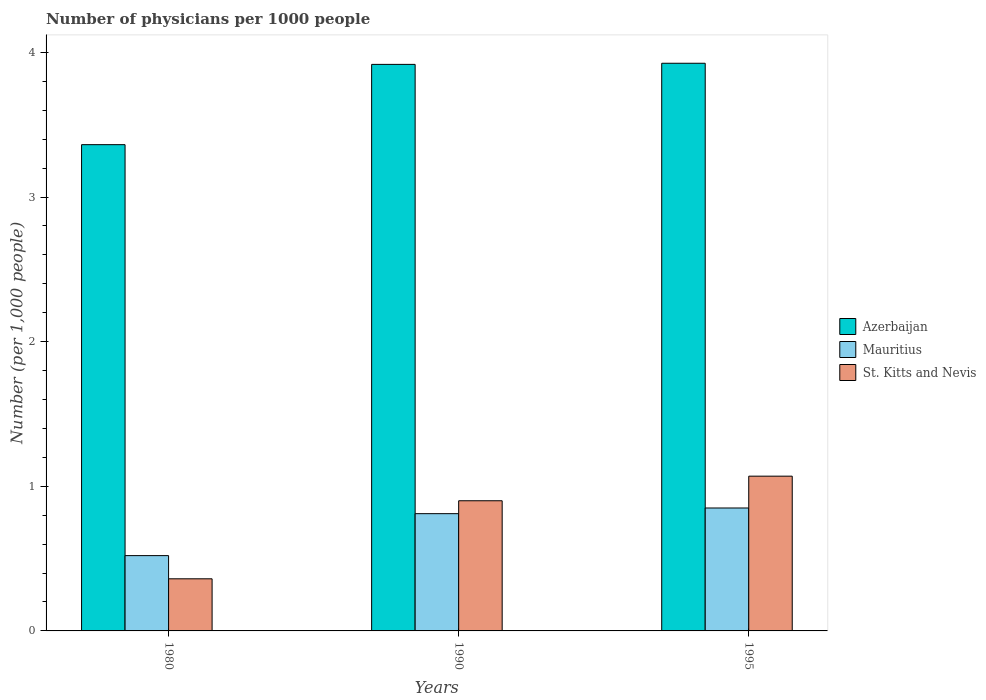How many different coloured bars are there?
Your answer should be compact. 3. Are the number of bars per tick equal to the number of legend labels?
Give a very brief answer. Yes. Are the number of bars on each tick of the X-axis equal?
Keep it short and to the point. Yes. How many bars are there on the 1st tick from the left?
Your response must be concise. 3. How many bars are there on the 1st tick from the right?
Give a very brief answer. 3. What is the number of physicians in St. Kitts and Nevis in 1990?
Ensure brevity in your answer.  0.9. Across all years, what is the maximum number of physicians in Azerbaijan?
Make the answer very short. 3.92. Across all years, what is the minimum number of physicians in Azerbaijan?
Ensure brevity in your answer.  3.36. What is the total number of physicians in Azerbaijan in the graph?
Your answer should be compact. 11.2. What is the difference between the number of physicians in Azerbaijan in 1980 and that in 1990?
Make the answer very short. -0.56. What is the difference between the number of physicians in St. Kitts and Nevis in 1995 and the number of physicians in Azerbaijan in 1990?
Offer a terse response. -2.85. What is the average number of physicians in Azerbaijan per year?
Give a very brief answer. 3.73. In the year 1990, what is the difference between the number of physicians in Azerbaijan and number of physicians in St. Kitts and Nevis?
Offer a very short reply. 3.02. In how many years, is the number of physicians in Azerbaijan greater than 2.4?
Your answer should be very brief. 3. What is the ratio of the number of physicians in St. Kitts and Nevis in 1980 to that in 1995?
Give a very brief answer. 0.34. Is the difference between the number of physicians in Azerbaijan in 1980 and 1990 greater than the difference between the number of physicians in St. Kitts and Nevis in 1980 and 1990?
Offer a terse response. No. What is the difference between the highest and the second highest number of physicians in Mauritius?
Keep it short and to the point. 0.04. What is the difference between the highest and the lowest number of physicians in Azerbaijan?
Give a very brief answer. 0.56. In how many years, is the number of physicians in St. Kitts and Nevis greater than the average number of physicians in St. Kitts and Nevis taken over all years?
Offer a very short reply. 2. Is the sum of the number of physicians in Azerbaijan in 1990 and 1995 greater than the maximum number of physicians in St. Kitts and Nevis across all years?
Offer a very short reply. Yes. What does the 1st bar from the left in 1980 represents?
Your answer should be compact. Azerbaijan. What does the 3rd bar from the right in 1990 represents?
Offer a terse response. Azerbaijan. How many years are there in the graph?
Provide a short and direct response. 3. Does the graph contain any zero values?
Your answer should be compact. No. Where does the legend appear in the graph?
Ensure brevity in your answer.  Center right. How many legend labels are there?
Your response must be concise. 3. How are the legend labels stacked?
Your response must be concise. Vertical. What is the title of the graph?
Keep it short and to the point. Number of physicians per 1000 people. Does "Aruba" appear as one of the legend labels in the graph?
Ensure brevity in your answer.  No. What is the label or title of the X-axis?
Make the answer very short. Years. What is the label or title of the Y-axis?
Keep it short and to the point. Number (per 1,0 people). What is the Number (per 1,000 people) of Azerbaijan in 1980?
Your answer should be compact. 3.36. What is the Number (per 1,000 people) of Mauritius in 1980?
Your answer should be very brief. 0.52. What is the Number (per 1,000 people) of St. Kitts and Nevis in 1980?
Your response must be concise. 0.36. What is the Number (per 1,000 people) of Azerbaijan in 1990?
Ensure brevity in your answer.  3.92. What is the Number (per 1,000 people) of Mauritius in 1990?
Provide a short and direct response. 0.81. What is the Number (per 1,000 people) in St. Kitts and Nevis in 1990?
Your response must be concise. 0.9. What is the Number (per 1,000 people) in Azerbaijan in 1995?
Your answer should be compact. 3.92. What is the Number (per 1,000 people) of Mauritius in 1995?
Provide a succinct answer. 0.85. What is the Number (per 1,000 people) in St. Kitts and Nevis in 1995?
Ensure brevity in your answer.  1.07. Across all years, what is the maximum Number (per 1,000 people) in Azerbaijan?
Ensure brevity in your answer.  3.92. Across all years, what is the maximum Number (per 1,000 people) of Mauritius?
Offer a terse response. 0.85. Across all years, what is the maximum Number (per 1,000 people) in St. Kitts and Nevis?
Keep it short and to the point. 1.07. Across all years, what is the minimum Number (per 1,000 people) in Azerbaijan?
Make the answer very short. 3.36. Across all years, what is the minimum Number (per 1,000 people) in Mauritius?
Your answer should be very brief. 0.52. Across all years, what is the minimum Number (per 1,000 people) in St. Kitts and Nevis?
Make the answer very short. 0.36. What is the total Number (per 1,000 people) in Azerbaijan in the graph?
Make the answer very short. 11.2. What is the total Number (per 1,000 people) of Mauritius in the graph?
Offer a terse response. 2.18. What is the total Number (per 1,000 people) of St. Kitts and Nevis in the graph?
Make the answer very short. 2.33. What is the difference between the Number (per 1,000 people) in Azerbaijan in 1980 and that in 1990?
Give a very brief answer. -0.56. What is the difference between the Number (per 1,000 people) in Mauritius in 1980 and that in 1990?
Offer a terse response. -0.29. What is the difference between the Number (per 1,000 people) in St. Kitts and Nevis in 1980 and that in 1990?
Your answer should be very brief. -0.54. What is the difference between the Number (per 1,000 people) of Azerbaijan in 1980 and that in 1995?
Ensure brevity in your answer.  -0.56. What is the difference between the Number (per 1,000 people) in Mauritius in 1980 and that in 1995?
Ensure brevity in your answer.  -0.33. What is the difference between the Number (per 1,000 people) of St. Kitts and Nevis in 1980 and that in 1995?
Keep it short and to the point. -0.71. What is the difference between the Number (per 1,000 people) of Azerbaijan in 1990 and that in 1995?
Provide a short and direct response. -0.01. What is the difference between the Number (per 1,000 people) in Mauritius in 1990 and that in 1995?
Offer a very short reply. -0.04. What is the difference between the Number (per 1,000 people) in St. Kitts and Nevis in 1990 and that in 1995?
Offer a very short reply. -0.17. What is the difference between the Number (per 1,000 people) of Azerbaijan in 1980 and the Number (per 1,000 people) of Mauritius in 1990?
Offer a terse response. 2.55. What is the difference between the Number (per 1,000 people) in Azerbaijan in 1980 and the Number (per 1,000 people) in St. Kitts and Nevis in 1990?
Your answer should be very brief. 2.46. What is the difference between the Number (per 1,000 people) in Mauritius in 1980 and the Number (per 1,000 people) in St. Kitts and Nevis in 1990?
Offer a very short reply. -0.38. What is the difference between the Number (per 1,000 people) in Azerbaijan in 1980 and the Number (per 1,000 people) in Mauritius in 1995?
Offer a very short reply. 2.51. What is the difference between the Number (per 1,000 people) in Azerbaijan in 1980 and the Number (per 1,000 people) in St. Kitts and Nevis in 1995?
Make the answer very short. 2.29. What is the difference between the Number (per 1,000 people) of Mauritius in 1980 and the Number (per 1,000 people) of St. Kitts and Nevis in 1995?
Give a very brief answer. -0.55. What is the difference between the Number (per 1,000 people) of Azerbaijan in 1990 and the Number (per 1,000 people) of Mauritius in 1995?
Ensure brevity in your answer.  3.07. What is the difference between the Number (per 1,000 people) of Azerbaijan in 1990 and the Number (per 1,000 people) of St. Kitts and Nevis in 1995?
Give a very brief answer. 2.85. What is the difference between the Number (per 1,000 people) in Mauritius in 1990 and the Number (per 1,000 people) in St. Kitts and Nevis in 1995?
Your response must be concise. -0.26. What is the average Number (per 1,000 people) in Azerbaijan per year?
Offer a very short reply. 3.73. What is the average Number (per 1,000 people) of Mauritius per year?
Give a very brief answer. 0.73. What is the average Number (per 1,000 people) in St. Kitts and Nevis per year?
Your response must be concise. 0.78. In the year 1980, what is the difference between the Number (per 1,000 people) in Azerbaijan and Number (per 1,000 people) in Mauritius?
Your answer should be very brief. 2.84. In the year 1980, what is the difference between the Number (per 1,000 people) in Azerbaijan and Number (per 1,000 people) in St. Kitts and Nevis?
Ensure brevity in your answer.  3. In the year 1980, what is the difference between the Number (per 1,000 people) of Mauritius and Number (per 1,000 people) of St. Kitts and Nevis?
Ensure brevity in your answer.  0.16. In the year 1990, what is the difference between the Number (per 1,000 people) of Azerbaijan and Number (per 1,000 people) of Mauritius?
Provide a succinct answer. 3.11. In the year 1990, what is the difference between the Number (per 1,000 people) in Azerbaijan and Number (per 1,000 people) in St. Kitts and Nevis?
Your response must be concise. 3.02. In the year 1990, what is the difference between the Number (per 1,000 people) in Mauritius and Number (per 1,000 people) in St. Kitts and Nevis?
Ensure brevity in your answer.  -0.09. In the year 1995, what is the difference between the Number (per 1,000 people) in Azerbaijan and Number (per 1,000 people) in Mauritius?
Your answer should be compact. 3.08. In the year 1995, what is the difference between the Number (per 1,000 people) in Azerbaijan and Number (per 1,000 people) in St. Kitts and Nevis?
Offer a very short reply. 2.85. In the year 1995, what is the difference between the Number (per 1,000 people) in Mauritius and Number (per 1,000 people) in St. Kitts and Nevis?
Provide a short and direct response. -0.22. What is the ratio of the Number (per 1,000 people) in Azerbaijan in 1980 to that in 1990?
Offer a very short reply. 0.86. What is the ratio of the Number (per 1,000 people) in Mauritius in 1980 to that in 1990?
Offer a very short reply. 0.64. What is the ratio of the Number (per 1,000 people) in St. Kitts and Nevis in 1980 to that in 1990?
Provide a short and direct response. 0.4. What is the ratio of the Number (per 1,000 people) in Azerbaijan in 1980 to that in 1995?
Ensure brevity in your answer.  0.86. What is the ratio of the Number (per 1,000 people) in Mauritius in 1980 to that in 1995?
Provide a short and direct response. 0.61. What is the ratio of the Number (per 1,000 people) in St. Kitts and Nevis in 1980 to that in 1995?
Your answer should be compact. 0.34. What is the ratio of the Number (per 1,000 people) in Azerbaijan in 1990 to that in 1995?
Give a very brief answer. 1. What is the ratio of the Number (per 1,000 people) of Mauritius in 1990 to that in 1995?
Provide a succinct answer. 0.95. What is the ratio of the Number (per 1,000 people) in St. Kitts and Nevis in 1990 to that in 1995?
Make the answer very short. 0.84. What is the difference between the highest and the second highest Number (per 1,000 people) in Azerbaijan?
Make the answer very short. 0.01. What is the difference between the highest and the second highest Number (per 1,000 people) of Mauritius?
Ensure brevity in your answer.  0.04. What is the difference between the highest and the second highest Number (per 1,000 people) in St. Kitts and Nevis?
Your response must be concise. 0.17. What is the difference between the highest and the lowest Number (per 1,000 people) in Azerbaijan?
Give a very brief answer. 0.56. What is the difference between the highest and the lowest Number (per 1,000 people) of Mauritius?
Your answer should be very brief. 0.33. What is the difference between the highest and the lowest Number (per 1,000 people) in St. Kitts and Nevis?
Provide a short and direct response. 0.71. 